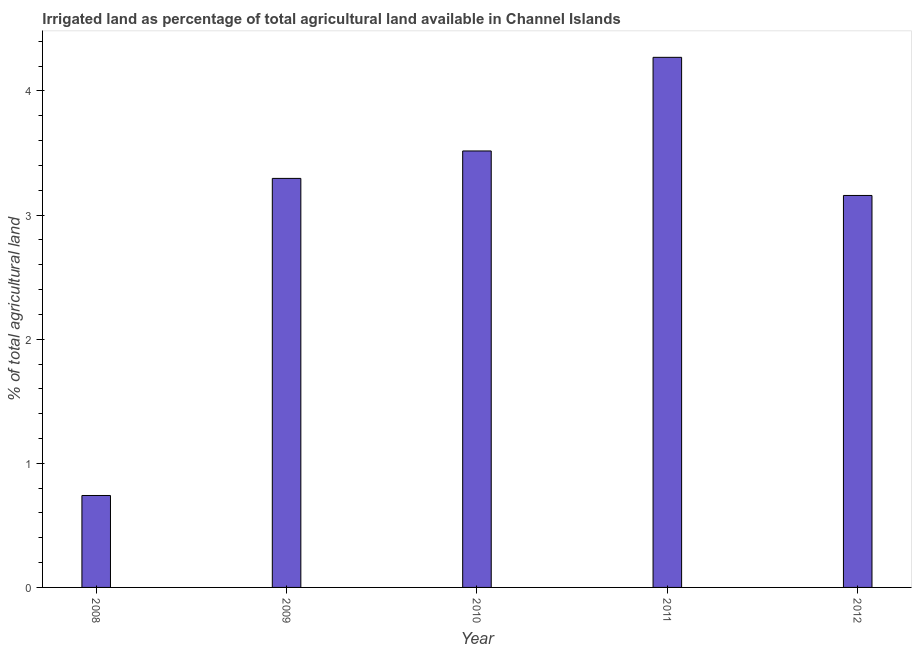Does the graph contain grids?
Provide a short and direct response. No. What is the title of the graph?
Your response must be concise. Irrigated land as percentage of total agricultural land available in Channel Islands. What is the label or title of the Y-axis?
Offer a very short reply. % of total agricultural land. What is the percentage of agricultural irrigated land in 2010?
Provide a succinct answer. 3.52. Across all years, what is the maximum percentage of agricultural irrigated land?
Offer a terse response. 4.27. Across all years, what is the minimum percentage of agricultural irrigated land?
Keep it short and to the point. 0.74. What is the sum of the percentage of agricultural irrigated land?
Your response must be concise. 14.98. What is the difference between the percentage of agricultural irrigated land in 2008 and 2010?
Provide a short and direct response. -2.78. What is the average percentage of agricultural irrigated land per year?
Provide a succinct answer. 3. What is the median percentage of agricultural irrigated land?
Your response must be concise. 3.3. In how many years, is the percentage of agricultural irrigated land greater than 1.2 %?
Ensure brevity in your answer.  4. Do a majority of the years between 2008 and 2012 (inclusive) have percentage of agricultural irrigated land greater than 3.2 %?
Your answer should be compact. Yes. What is the ratio of the percentage of agricultural irrigated land in 2008 to that in 2009?
Your answer should be very brief. 0.23. What is the difference between the highest and the second highest percentage of agricultural irrigated land?
Your answer should be very brief. 0.75. Is the sum of the percentage of agricultural irrigated land in 2008 and 2010 greater than the maximum percentage of agricultural irrigated land across all years?
Keep it short and to the point. No. What is the difference between the highest and the lowest percentage of agricultural irrigated land?
Give a very brief answer. 3.53. Are all the bars in the graph horizontal?
Keep it short and to the point. No. What is the % of total agricultural land in 2008?
Provide a short and direct response. 0.74. What is the % of total agricultural land of 2009?
Your answer should be compact. 3.3. What is the % of total agricultural land in 2010?
Keep it short and to the point. 3.52. What is the % of total agricultural land of 2011?
Provide a succinct answer. 4.27. What is the % of total agricultural land of 2012?
Offer a very short reply. 3.16. What is the difference between the % of total agricultural land in 2008 and 2009?
Provide a short and direct response. -2.55. What is the difference between the % of total agricultural land in 2008 and 2010?
Keep it short and to the point. -2.78. What is the difference between the % of total agricultural land in 2008 and 2011?
Your answer should be very brief. -3.53. What is the difference between the % of total agricultural land in 2008 and 2012?
Provide a succinct answer. -2.42. What is the difference between the % of total agricultural land in 2009 and 2010?
Your response must be concise. -0.22. What is the difference between the % of total agricultural land in 2009 and 2011?
Keep it short and to the point. -0.98. What is the difference between the % of total agricultural land in 2009 and 2012?
Ensure brevity in your answer.  0.14. What is the difference between the % of total agricultural land in 2010 and 2011?
Keep it short and to the point. -0.75. What is the difference between the % of total agricultural land in 2010 and 2012?
Keep it short and to the point. 0.36. What is the difference between the % of total agricultural land in 2011 and 2012?
Give a very brief answer. 1.11. What is the ratio of the % of total agricultural land in 2008 to that in 2009?
Keep it short and to the point. 0.23. What is the ratio of the % of total agricultural land in 2008 to that in 2010?
Keep it short and to the point. 0.21. What is the ratio of the % of total agricultural land in 2008 to that in 2011?
Provide a succinct answer. 0.17. What is the ratio of the % of total agricultural land in 2008 to that in 2012?
Give a very brief answer. 0.23. What is the ratio of the % of total agricultural land in 2009 to that in 2010?
Your response must be concise. 0.94. What is the ratio of the % of total agricultural land in 2009 to that in 2011?
Your response must be concise. 0.77. What is the ratio of the % of total agricultural land in 2009 to that in 2012?
Offer a very short reply. 1.04. What is the ratio of the % of total agricultural land in 2010 to that in 2011?
Your response must be concise. 0.82. What is the ratio of the % of total agricultural land in 2010 to that in 2012?
Keep it short and to the point. 1.11. What is the ratio of the % of total agricultural land in 2011 to that in 2012?
Your response must be concise. 1.35. 